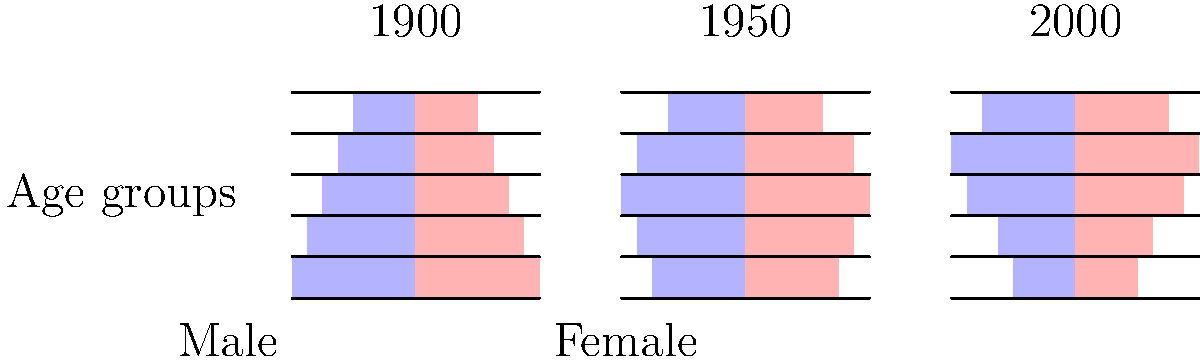Analyze the population pyramids representing Central Asian demographic shifts from 1900 to 2000. Which of the following statements best describes the trend observed?

A) The population has become increasingly youthful over time
B) The population has aged significantly over the century
C) The population structure has remained relatively stable
D) The middle-age group has expanded while both young and old populations have decreased To answer this question, we need to analyze the population pyramids for each time period:

1. 1900 pyramid:
   - Wide base, indicating a large young population
   - Narrowing towards the top, suggesting fewer older individuals

2. 1950 pyramid:
   - Slightly narrower base compared to 1900
   - Expanded middle section
   - Still narrowing towards the top, but less dramatically

3. 2000 pyramid:
   - Significantly narrower base compared to both 1900 and 1950
   - Expanded middle and upper-middle sections
   - Top section slightly wider than previous periods

Analyzing these changes:
- The proportion of young people (base of the pyramid) has decreased over time
- The middle-age group has expanded considerably
- The older population has slightly increased

This trend indicates an overall aging of the population, with fewer young people and more middle-aged and older individuals. The change is most dramatic between 1900 and 2000.

Therefore, the statement that best describes this trend is B) The population has aged significantly over the century.
Answer: B) The population has aged significantly over the century 